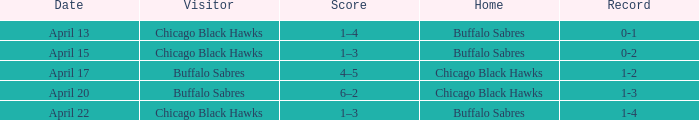Which Home is on april 22? Buffalo Sabres. 